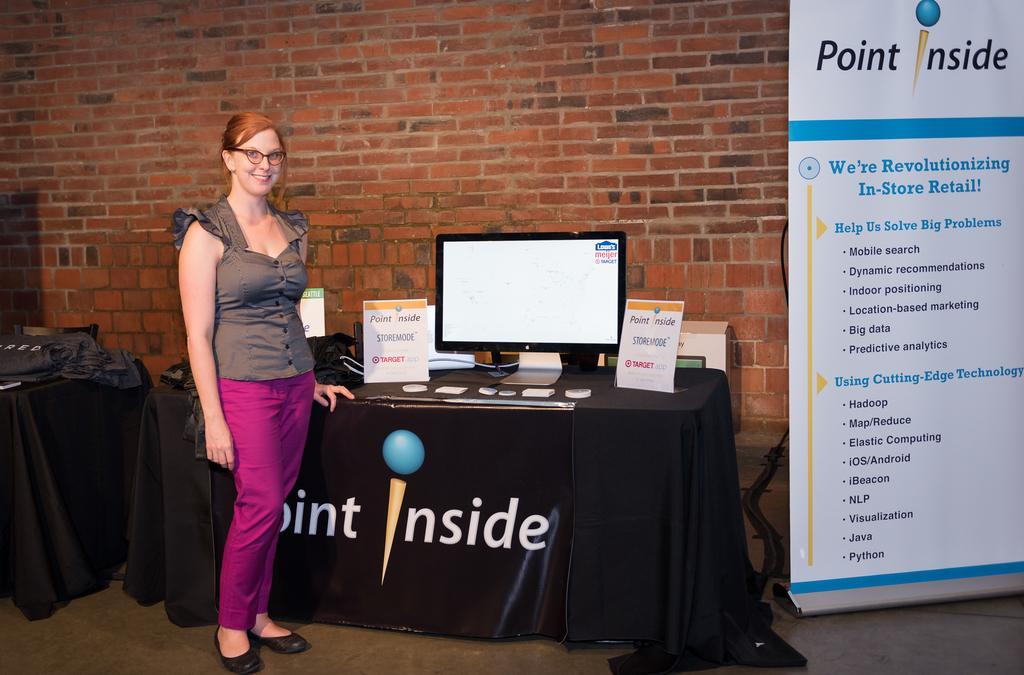Please provide a concise description of this image. In this image, we can see a woman is standing and smiling near the tables. That is covered with black clothes. Here we can see so many objects, things are placed on the tables. Background there is a brick wall. Right side of the image, we can see a banner. Here we can see a monitor. 